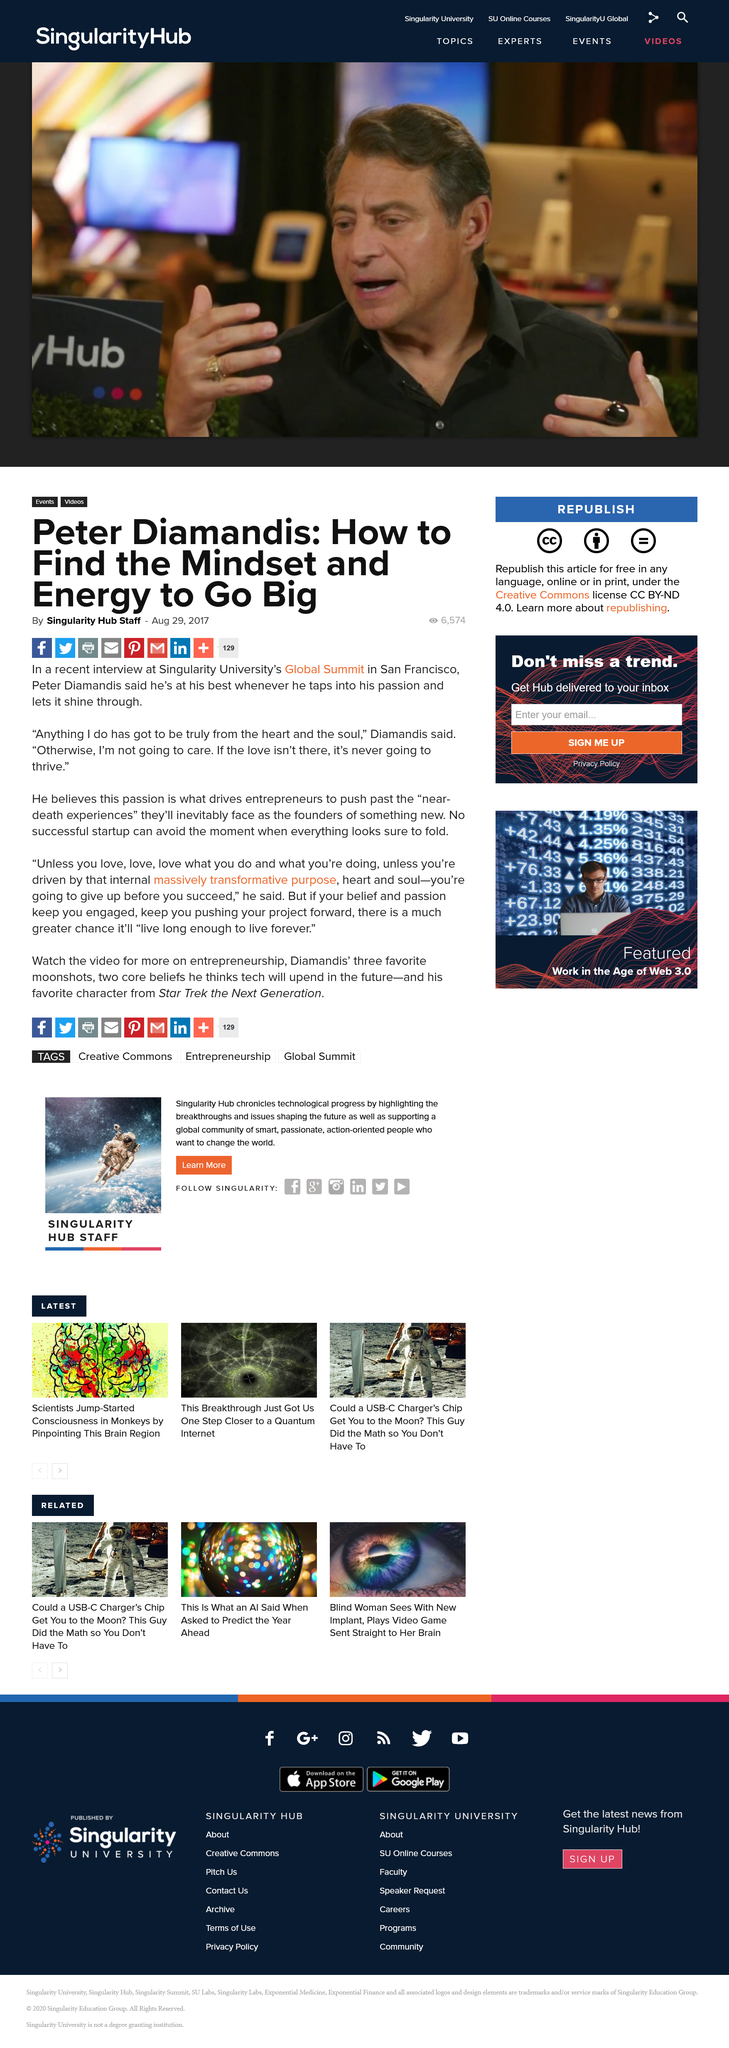Point out several critical features in this image. If you lack passion and drive in your work, you will likely give up before achieving success, as per Peter Diamandis's belief. Entrepreneurs are driven by passion, according to Peter Diamandis, even in the face of the inevitable "near-death experiences" they will encounter as the founders of something new. Peter Diamandis is at his best when he taps into his passion and lets it shine through. 